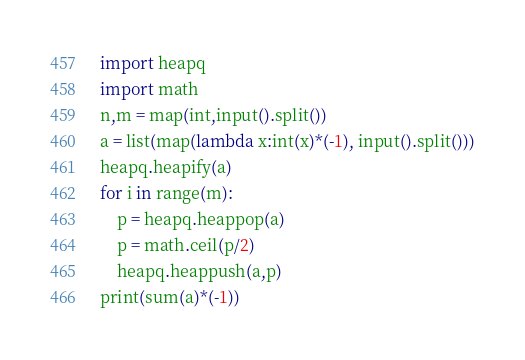<code> <loc_0><loc_0><loc_500><loc_500><_Python_>import heapq 
import math 
n,m = map(int,input().split())
a = list(map(lambda x:int(x)*(-1), input().split()))
heapq.heapify(a)
for i in range(m):
    p = heapq.heappop(a)
    p = math.ceil(p/2)
    heapq.heappush(a,p)
print(sum(a)*(-1))</code> 